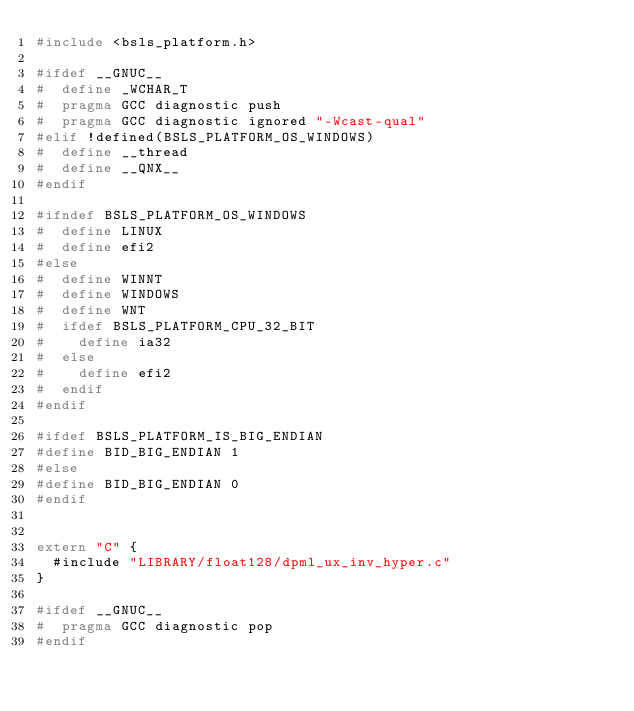Convert code to text. <code><loc_0><loc_0><loc_500><loc_500><_C++_>#include <bsls_platform.h>

#ifdef __GNUC__
#  define _WCHAR_T
#  pragma GCC diagnostic push
#  pragma GCC diagnostic ignored "-Wcast-qual"
#elif !defined(BSLS_PLATFORM_OS_WINDOWS)
#  define __thread
#  define __QNX__
#endif

#ifndef BSLS_PLATFORM_OS_WINDOWS
#  define LINUX
#  define efi2
#else
#  define WINNT
#  define WINDOWS
#  define WNT
#  ifdef BSLS_PLATFORM_CPU_32_BIT
#    define ia32
#  else
#    define efi2
#  endif
#endif

#ifdef BSLS_PLATFORM_IS_BIG_ENDIAN
#define BID_BIG_ENDIAN 1
#else
#define BID_BIG_ENDIAN 0
#endif


extern "C" {
  #include "LIBRARY/float128/dpml_ux_inv_hyper.c"
}

#ifdef __GNUC__
#  pragma GCC diagnostic pop
#endif
</code> 